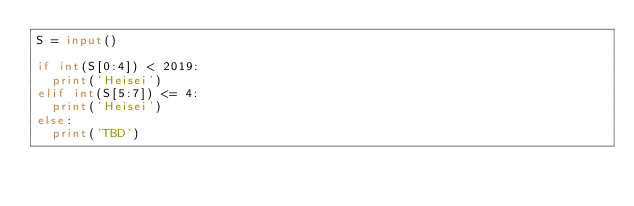<code> <loc_0><loc_0><loc_500><loc_500><_Python_>S = input()

if int(S[0:4]) < 2019:
  print('Heisei')
elif int(S[5:7]) <= 4:
  print('Heisei')
else:
  print('TBD')</code> 